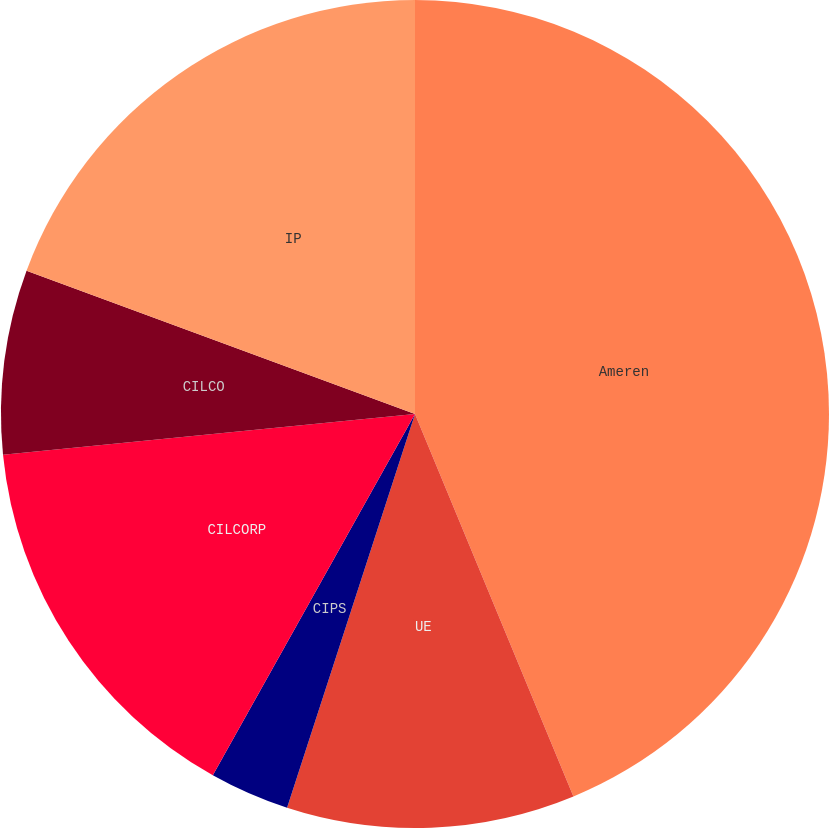<chart> <loc_0><loc_0><loc_500><loc_500><pie_chart><fcel>Ameren<fcel>UE<fcel>CIPS<fcel>CILCORP<fcel>CILCO<fcel>IP<nl><fcel>43.75%<fcel>11.25%<fcel>3.12%<fcel>15.31%<fcel>7.19%<fcel>19.38%<nl></chart> 